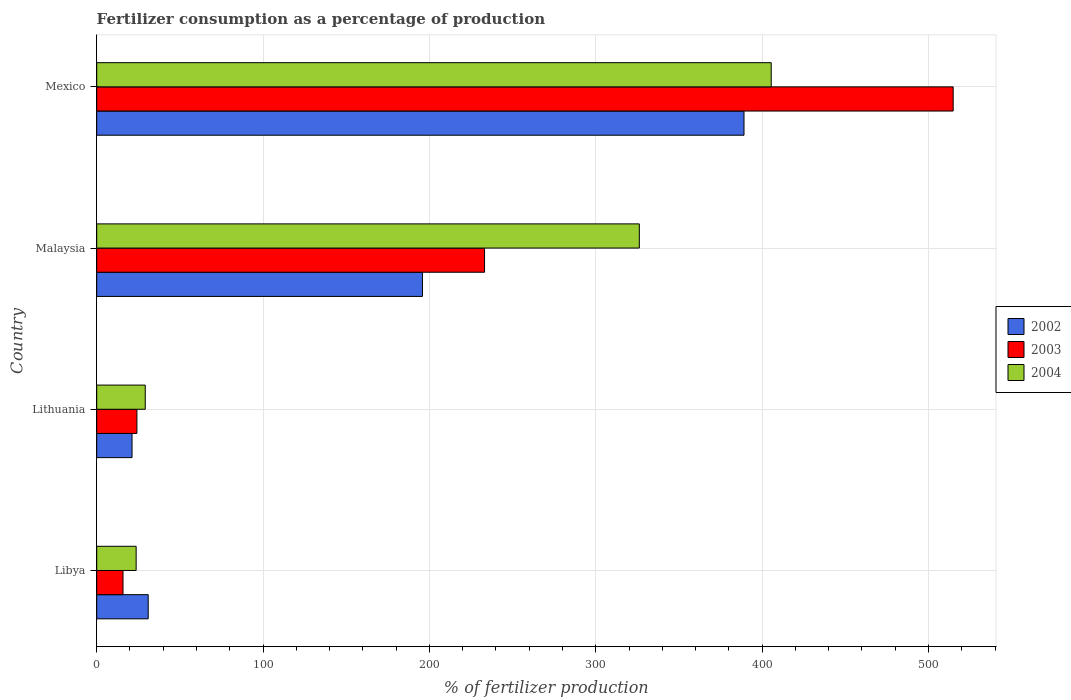How many different coloured bars are there?
Ensure brevity in your answer.  3. How many groups of bars are there?
Provide a short and direct response. 4. What is the label of the 1st group of bars from the top?
Ensure brevity in your answer.  Mexico. In how many cases, is the number of bars for a given country not equal to the number of legend labels?
Make the answer very short. 0. What is the percentage of fertilizers consumed in 2003 in Lithuania?
Provide a short and direct response. 24.16. Across all countries, what is the maximum percentage of fertilizers consumed in 2004?
Offer a terse response. 405.44. Across all countries, what is the minimum percentage of fertilizers consumed in 2002?
Keep it short and to the point. 21.23. In which country was the percentage of fertilizers consumed in 2002 maximum?
Your answer should be compact. Mexico. In which country was the percentage of fertilizers consumed in 2003 minimum?
Keep it short and to the point. Libya. What is the total percentage of fertilizers consumed in 2003 in the graph?
Ensure brevity in your answer.  787.9. What is the difference between the percentage of fertilizers consumed in 2002 in Libya and that in Mexico?
Keep it short and to the point. -358.13. What is the difference between the percentage of fertilizers consumed in 2002 in Malaysia and the percentage of fertilizers consumed in 2004 in Lithuania?
Ensure brevity in your answer.  166.62. What is the average percentage of fertilizers consumed in 2004 per country?
Make the answer very short. 196.12. What is the difference between the percentage of fertilizers consumed in 2002 and percentage of fertilizers consumed in 2003 in Mexico?
Your answer should be very brief. -125.73. What is the ratio of the percentage of fertilizers consumed in 2004 in Lithuania to that in Malaysia?
Your answer should be very brief. 0.09. What is the difference between the highest and the second highest percentage of fertilizers consumed in 2003?
Keep it short and to the point. 281.69. What is the difference between the highest and the lowest percentage of fertilizers consumed in 2003?
Keep it short and to the point. 498.99. What does the 1st bar from the top in Lithuania represents?
Ensure brevity in your answer.  2004. What does the 2nd bar from the bottom in Lithuania represents?
Offer a very short reply. 2003. Is it the case that in every country, the sum of the percentage of fertilizers consumed in 2003 and percentage of fertilizers consumed in 2004 is greater than the percentage of fertilizers consumed in 2002?
Offer a terse response. Yes. Are all the bars in the graph horizontal?
Your answer should be very brief. Yes. How many countries are there in the graph?
Keep it short and to the point. 4. What is the difference between two consecutive major ticks on the X-axis?
Your answer should be compact. 100. Are the values on the major ticks of X-axis written in scientific E-notation?
Give a very brief answer. No. Does the graph contain grids?
Offer a very short reply. Yes. How are the legend labels stacked?
Give a very brief answer. Vertical. What is the title of the graph?
Offer a terse response. Fertilizer consumption as a percentage of production. What is the label or title of the X-axis?
Ensure brevity in your answer.  % of fertilizer production. What is the % of fertilizer production in 2002 in Libya?
Your response must be concise. 30.95. What is the % of fertilizer production in 2003 in Libya?
Give a very brief answer. 15.82. What is the % of fertilizer production of 2004 in Libya?
Ensure brevity in your answer.  23.71. What is the % of fertilizer production in 2002 in Lithuania?
Offer a terse response. 21.23. What is the % of fertilizer production of 2003 in Lithuania?
Your answer should be compact. 24.16. What is the % of fertilizer production in 2004 in Lithuania?
Provide a succinct answer. 29.18. What is the % of fertilizer production in 2002 in Malaysia?
Give a very brief answer. 195.8. What is the % of fertilizer production of 2003 in Malaysia?
Provide a short and direct response. 233.12. What is the % of fertilizer production of 2004 in Malaysia?
Give a very brief answer. 326.16. What is the % of fertilizer production of 2002 in Mexico?
Offer a very short reply. 389.08. What is the % of fertilizer production of 2003 in Mexico?
Give a very brief answer. 514.81. What is the % of fertilizer production in 2004 in Mexico?
Ensure brevity in your answer.  405.44. Across all countries, what is the maximum % of fertilizer production in 2002?
Make the answer very short. 389.08. Across all countries, what is the maximum % of fertilizer production of 2003?
Give a very brief answer. 514.81. Across all countries, what is the maximum % of fertilizer production of 2004?
Your answer should be compact. 405.44. Across all countries, what is the minimum % of fertilizer production of 2002?
Offer a very short reply. 21.23. Across all countries, what is the minimum % of fertilizer production in 2003?
Offer a terse response. 15.82. Across all countries, what is the minimum % of fertilizer production in 2004?
Offer a terse response. 23.71. What is the total % of fertilizer production in 2002 in the graph?
Your answer should be very brief. 637.07. What is the total % of fertilizer production of 2003 in the graph?
Your answer should be very brief. 787.9. What is the total % of fertilizer production of 2004 in the graph?
Give a very brief answer. 784.48. What is the difference between the % of fertilizer production of 2002 in Libya and that in Lithuania?
Your response must be concise. 9.72. What is the difference between the % of fertilizer production of 2003 in Libya and that in Lithuania?
Make the answer very short. -8.35. What is the difference between the % of fertilizer production of 2004 in Libya and that in Lithuania?
Your response must be concise. -5.48. What is the difference between the % of fertilizer production of 2002 in Libya and that in Malaysia?
Your response must be concise. -164.85. What is the difference between the % of fertilizer production in 2003 in Libya and that in Malaysia?
Offer a terse response. -217.3. What is the difference between the % of fertilizer production in 2004 in Libya and that in Malaysia?
Ensure brevity in your answer.  -302.45. What is the difference between the % of fertilizer production of 2002 in Libya and that in Mexico?
Keep it short and to the point. -358.13. What is the difference between the % of fertilizer production of 2003 in Libya and that in Mexico?
Your answer should be very brief. -498.99. What is the difference between the % of fertilizer production in 2004 in Libya and that in Mexico?
Ensure brevity in your answer.  -381.73. What is the difference between the % of fertilizer production of 2002 in Lithuania and that in Malaysia?
Make the answer very short. -174.57. What is the difference between the % of fertilizer production in 2003 in Lithuania and that in Malaysia?
Ensure brevity in your answer.  -208.96. What is the difference between the % of fertilizer production in 2004 in Lithuania and that in Malaysia?
Ensure brevity in your answer.  -296.98. What is the difference between the % of fertilizer production of 2002 in Lithuania and that in Mexico?
Keep it short and to the point. -367.85. What is the difference between the % of fertilizer production in 2003 in Lithuania and that in Mexico?
Provide a short and direct response. -490.64. What is the difference between the % of fertilizer production of 2004 in Lithuania and that in Mexico?
Your answer should be very brief. -376.26. What is the difference between the % of fertilizer production in 2002 in Malaysia and that in Mexico?
Provide a succinct answer. -193.28. What is the difference between the % of fertilizer production in 2003 in Malaysia and that in Mexico?
Provide a succinct answer. -281.69. What is the difference between the % of fertilizer production in 2004 in Malaysia and that in Mexico?
Provide a succinct answer. -79.28. What is the difference between the % of fertilizer production of 2002 in Libya and the % of fertilizer production of 2003 in Lithuania?
Keep it short and to the point. 6.79. What is the difference between the % of fertilizer production in 2002 in Libya and the % of fertilizer production in 2004 in Lithuania?
Your response must be concise. 1.77. What is the difference between the % of fertilizer production of 2003 in Libya and the % of fertilizer production of 2004 in Lithuania?
Make the answer very short. -13.37. What is the difference between the % of fertilizer production of 2002 in Libya and the % of fertilizer production of 2003 in Malaysia?
Your response must be concise. -202.17. What is the difference between the % of fertilizer production of 2002 in Libya and the % of fertilizer production of 2004 in Malaysia?
Offer a terse response. -295.2. What is the difference between the % of fertilizer production in 2003 in Libya and the % of fertilizer production in 2004 in Malaysia?
Your answer should be compact. -310.34. What is the difference between the % of fertilizer production of 2002 in Libya and the % of fertilizer production of 2003 in Mexico?
Your response must be concise. -483.85. What is the difference between the % of fertilizer production of 2002 in Libya and the % of fertilizer production of 2004 in Mexico?
Give a very brief answer. -374.48. What is the difference between the % of fertilizer production of 2003 in Libya and the % of fertilizer production of 2004 in Mexico?
Give a very brief answer. -389.62. What is the difference between the % of fertilizer production in 2002 in Lithuania and the % of fertilizer production in 2003 in Malaysia?
Offer a very short reply. -211.89. What is the difference between the % of fertilizer production in 2002 in Lithuania and the % of fertilizer production in 2004 in Malaysia?
Give a very brief answer. -304.93. What is the difference between the % of fertilizer production of 2003 in Lithuania and the % of fertilizer production of 2004 in Malaysia?
Provide a succinct answer. -302. What is the difference between the % of fertilizer production in 2002 in Lithuania and the % of fertilizer production in 2003 in Mexico?
Provide a short and direct response. -493.57. What is the difference between the % of fertilizer production in 2002 in Lithuania and the % of fertilizer production in 2004 in Mexico?
Offer a very short reply. -384.21. What is the difference between the % of fertilizer production in 2003 in Lithuania and the % of fertilizer production in 2004 in Mexico?
Offer a terse response. -381.28. What is the difference between the % of fertilizer production of 2002 in Malaysia and the % of fertilizer production of 2003 in Mexico?
Your response must be concise. -319. What is the difference between the % of fertilizer production of 2002 in Malaysia and the % of fertilizer production of 2004 in Mexico?
Make the answer very short. -209.64. What is the difference between the % of fertilizer production in 2003 in Malaysia and the % of fertilizer production in 2004 in Mexico?
Your answer should be very brief. -172.32. What is the average % of fertilizer production of 2002 per country?
Keep it short and to the point. 159.27. What is the average % of fertilizer production in 2003 per country?
Give a very brief answer. 196.98. What is the average % of fertilizer production of 2004 per country?
Give a very brief answer. 196.12. What is the difference between the % of fertilizer production of 2002 and % of fertilizer production of 2003 in Libya?
Provide a short and direct response. 15.14. What is the difference between the % of fertilizer production of 2002 and % of fertilizer production of 2004 in Libya?
Your response must be concise. 7.25. What is the difference between the % of fertilizer production of 2003 and % of fertilizer production of 2004 in Libya?
Offer a terse response. -7.89. What is the difference between the % of fertilizer production of 2002 and % of fertilizer production of 2003 in Lithuania?
Make the answer very short. -2.93. What is the difference between the % of fertilizer production in 2002 and % of fertilizer production in 2004 in Lithuania?
Your response must be concise. -7.95. What is the difference between the % of fertilizer production in 2003 and % of fertilizer production in 2004 in Lithuania?
Your response must be concise. -5.02. What is the difference between the % of fertilizer production in 2002 and % of fertilizer production in 2003 in Malaysia?
Offer a very short reply. -37.32. What is the difference between the % of fertilizer production in 2002 and % of fertilizer production in 2004 in Malaysia?
Provide a succinct answer. -130.36. What is the difference between the % of fertilizer production of 2003 and % of fertilizer production of 2004 in Malaysia?
Give a very brief answer. -93.04. What is the difference between the % of fertilizer production of 2002 and % of fertilizer production of 2003 in Mexico?
Offer a very short reply. -125.73. What is the difference between the % of fertilizer production of 2002 and % of fertilizer production of 2004 in Mexico?
Your answer should be compact. -16.36. What is the difference between the % of fertilizer production in 2003 and % of fertilizer production in 2004 in Mexico?
Your answer should be very brief. 109.37. What is the ratio of the % of fertilizer production in 2002 in Libya to that in Lithuania?
Your response must be concise. 1.46. What is the ratio of the % of fertilizer production of 2003 in Libya to that in Lithuania?
Provide a succinct answer. 0.65. What is the ratio of the % of fertilizer production of 2004 in Libya to that in Lithuania?
Your answer should be very brief. 0.81. What is the ratio of the % of fertilizer production of 2002 in Libya to that in Malaysia?
Your answer should be very brief. 0.16. What is the ratio of the % of fertilizer production in 2003 in Libya to that in Malaysia?
Your answer should be very brief. 0.07. What is the ratio of the % of fertilizer production in 2004 in Libya to that in Malaysia?
Give a very brief answer. 0.07. What is the ratio of the % of fertilizer production in 2002 in Libya to that in Mexico?
Keep it short and to the point. 0.08. What is the ratio of the % of fertilizer production of 2003 in Libya to that in Mexico?
Provide a succinct answer. 0.03. What is the ratio of the % of fertilizer production of 2004 in Libya to that in Mexico?
Offer a terse response. 0.06. What is the ratio of the % of fertilizer production of 2002 in Lithuania to that in Malaysia?
Offer a very short reply. 0.11. What is the ratio of the % of fertilizer production of 2003 in Lithuania to that in Malaysia?
Offer a terse response. 0.1. What is the ratio of the % of fertilizer production of 2004 in Lithuania to that in Malaysia?
Ensure brevity in your answer.  0.09. What is the ratio of the % of fertilizer production in 2002 in Lithuania to that in Mexico?
Provide a succinct answer. 0.05. What is the ratio of the % of fertilizer production in 2003 in Lithuania to that in Mexico?
Offer a terse response. 0.05. What is the ratio of the % of fertilizer production in 2004 in Lithuania to that in Mexico?
Give a very brief answer. 0.07. What is the ratio of the % of fertilizer production in 2002 in Malaysia to that in Mexico?
Your response must be concise. 0.5. What is the ratio of the % of fertilizer production of 2003 in Malaysia to that in Mexico?
Provide a succinct answer. 0.45. What is the ratio of the % of fertilizer production of 2004 in Malaysia to that in Mexico?
Provide a succinct answer. 0.8. What is the difference between the highest and the second highest % of fertilizer production of 2002?
Give a very brief answer. 193.28. What is the difference between the highest and the second highest % of fertilizer production of 2003?
Your response must be concise. 281.69. What is the difference between the highest and the second highest % of fertilizer production in 2004?
Make the answer very short. 79.28. What is the difference between the highest and the lowest % of fertilizer production of 2002?
Your answer should be very brief. 367.85. What is the difference between the highest and the lowest % of fertilizer production in 2003?
Ensure brevity in your answer.  498.99. What is the difference between the highest and the lowest % of fertilizer production of 2004?
Provide a short and direct response. 381.73. 